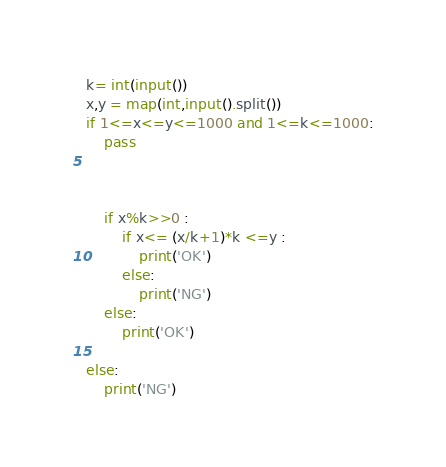Convert code to text. <code><loc_0><loc_0><loc_500><loc_500><_Python_>k= int(input())
x,y = map(int,input().split())
if 1<=x<=y<=1000 and 1<=k<=1000:
    pass



    if x%k>>0 :
        if x<= (x/k+1)*k <=y :
            print('OK')
        else:
            print('NG')
    else:
        print('OK')

else:
    print('NG')</code> 